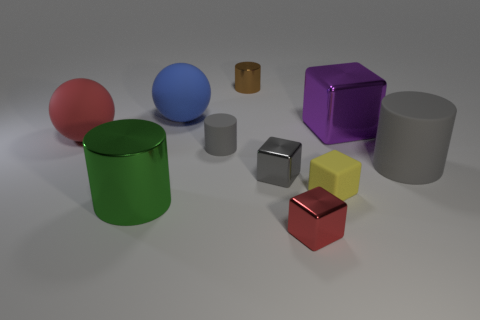Are there any objects in the image that are exactly the same shape and size? No objects share both the exact same shape and size. However, the two cylinders—the green and the smaller gray one—have similar shapes but differ in scale. 